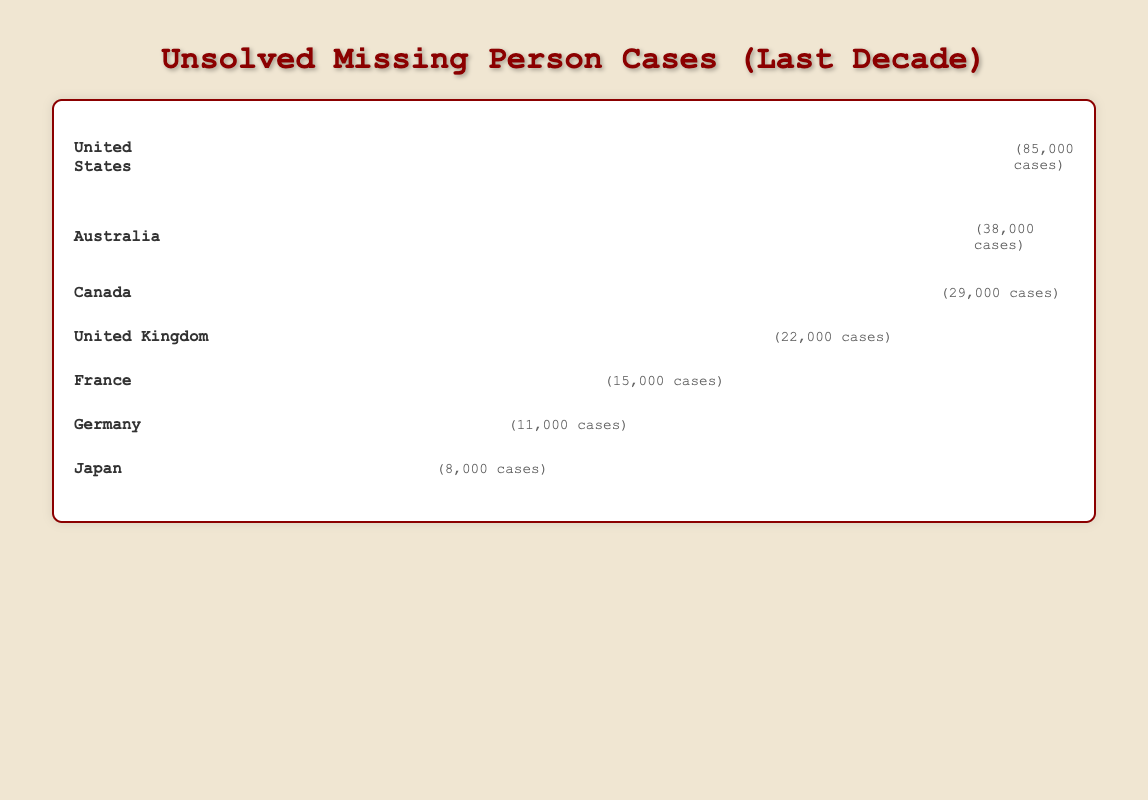How many unsolved missing person cases are recorded in Japan based on the Isotype Plot? Japan has a label with its country name and icons representing the number of unsolved cases. By looking at the label, we see that Japan has 8,000 cases.
Answer: 8,000 Which country has the highest number of unsolved missing person cases? The country with the most icons will have the highest number of cases. In this case, the United States has the most, as indicated by the numerous 'detective' icons and a count of 85,000 cases.
Answer: United States Compare the number of unsolved cases in Canada and the United Kingdom. Which country has more, and by how much? Canada and the UK are labeled with their countries and unsolved cases. Canada has 29,000 cases, and the UK has 22,000. Canada has 29,000 - 22,000 = 7,000 more cases than the UK.
Answer: Canada, 7,000 What is the average number of unsolved missing person cases across all the mentioned countries? Add up all the cases from each country and then divide by the number of countries. The total is 85,000 (US) + 38,000 (Australia) + 29,000 (Canada) + 22,000 (UK) + 15,000 (France) + 11,000 (Germany) + 8,000 (Japan) = 208,000. There are 7 countries, so the average is 208,000 / 7 ≈ 29,714 cases.
Answer: ~29,714 How many icons are displayed for the country with the fewest unsolved cases, and which country is it? The fewest unsolved missing person cases are in Japan, which has 8,000 cases. Each icon represents 1,000 cases, so 8,000 / 1,000 = 8 icons.
Answer: 8; Japan Which countries have unsolved missing person cases between 10,000 and 30,000? Examine the labels to identify countries within the range of 10,000 to 30,000 cases. Canada (29,000), the United Kingdom (22,000), France (15,000), and Germany (11,000) fall within this range.
Answer: Canada, United Kingdom, France, Germany What is the combined total of unsolved cases for European countries included in the plot? Identify European countries from the plot: United Kingdom (22,000), France (15,000), and Germany (11,000). Add their cases: 22,000 + 15,000 + 11,000 = 48,000.
Answer: 48,000 Which country uses the "magnifying_glass" icon, and how many cases does it represent? Look for the country labeled with the "magnifying_glass" icon. Australia uses this icon and represents 38,000 cases.
Answer: Australia, 38,000 